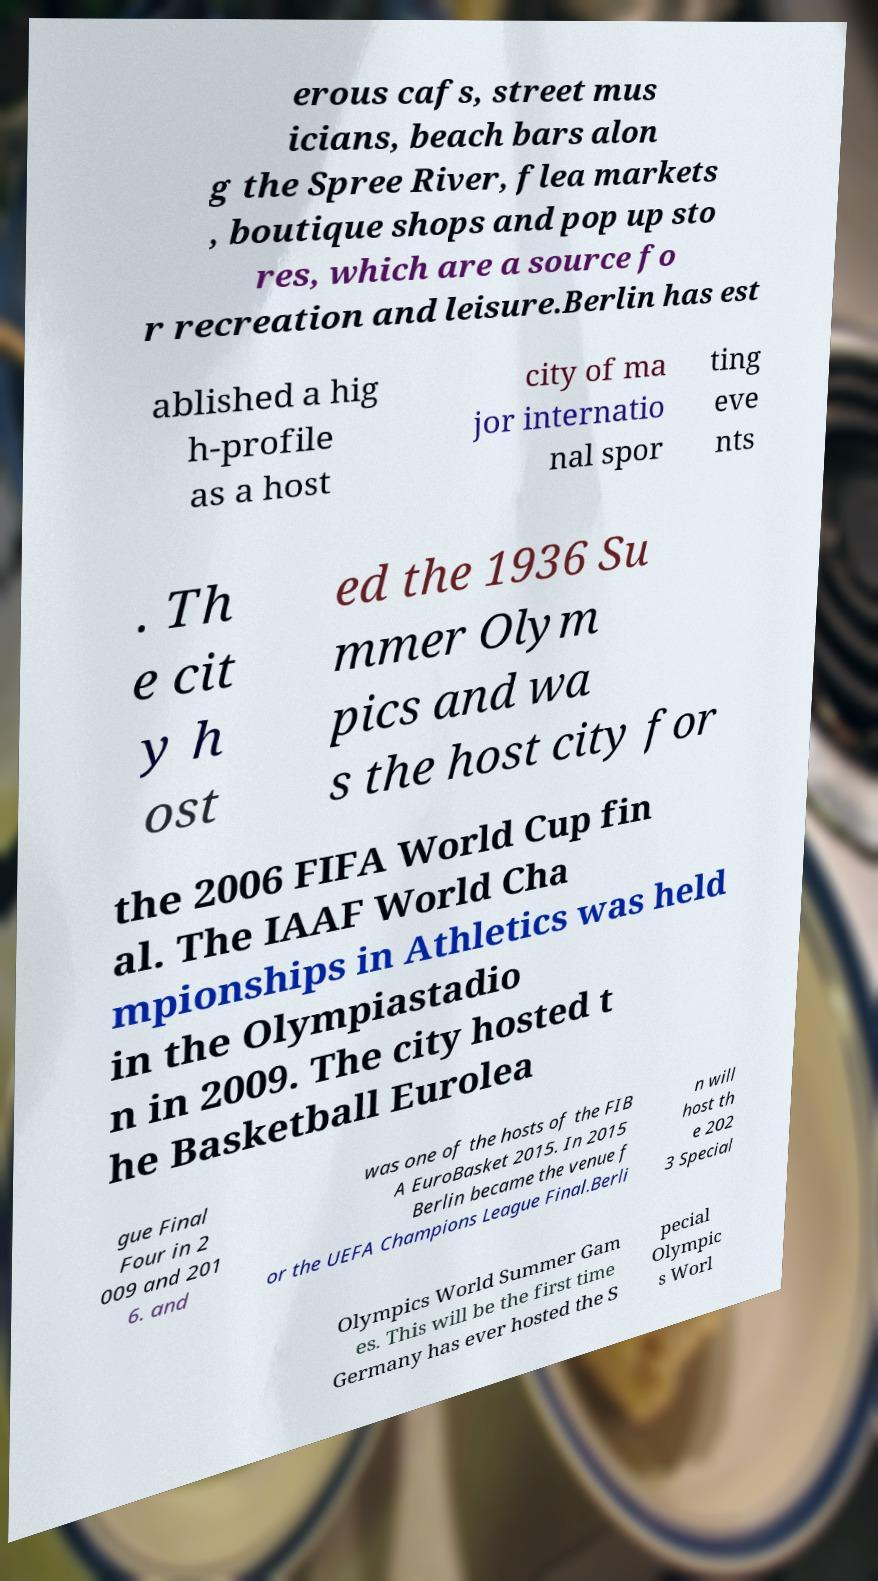Can you accurately transcribe the text from the provided image for me? erous cafs, street mus icians, beach bars alon g the Spree River, flea markets , boutique shops and pop up sto res, which are a source fo r recreation and leisure.Berlin has est ablished a hig h-profile as a host city of ma jor internatio nal spor ting eve nts . Th e cit y h ost ed the 1936 Su mmer Olym pics and wa s the host city for the 2006 FIFA World Cup fin al. The IAAF World Cha mpionships in Athletics was held in the Olympiastadio n in 2009. The city hosted t he Basketball Eurolea gue Final Four in 2 009 and 201 6. and was one of the hosts of the FIB A EuroBasket 2015. In 2015 Berlin became the venue f or the UEFA Champions League Final.Berli n will host th e 202 3 Special Olympics World Summer Gam es. This will be the first time Germany has ever hosted the S pecial Olympic s Worl 